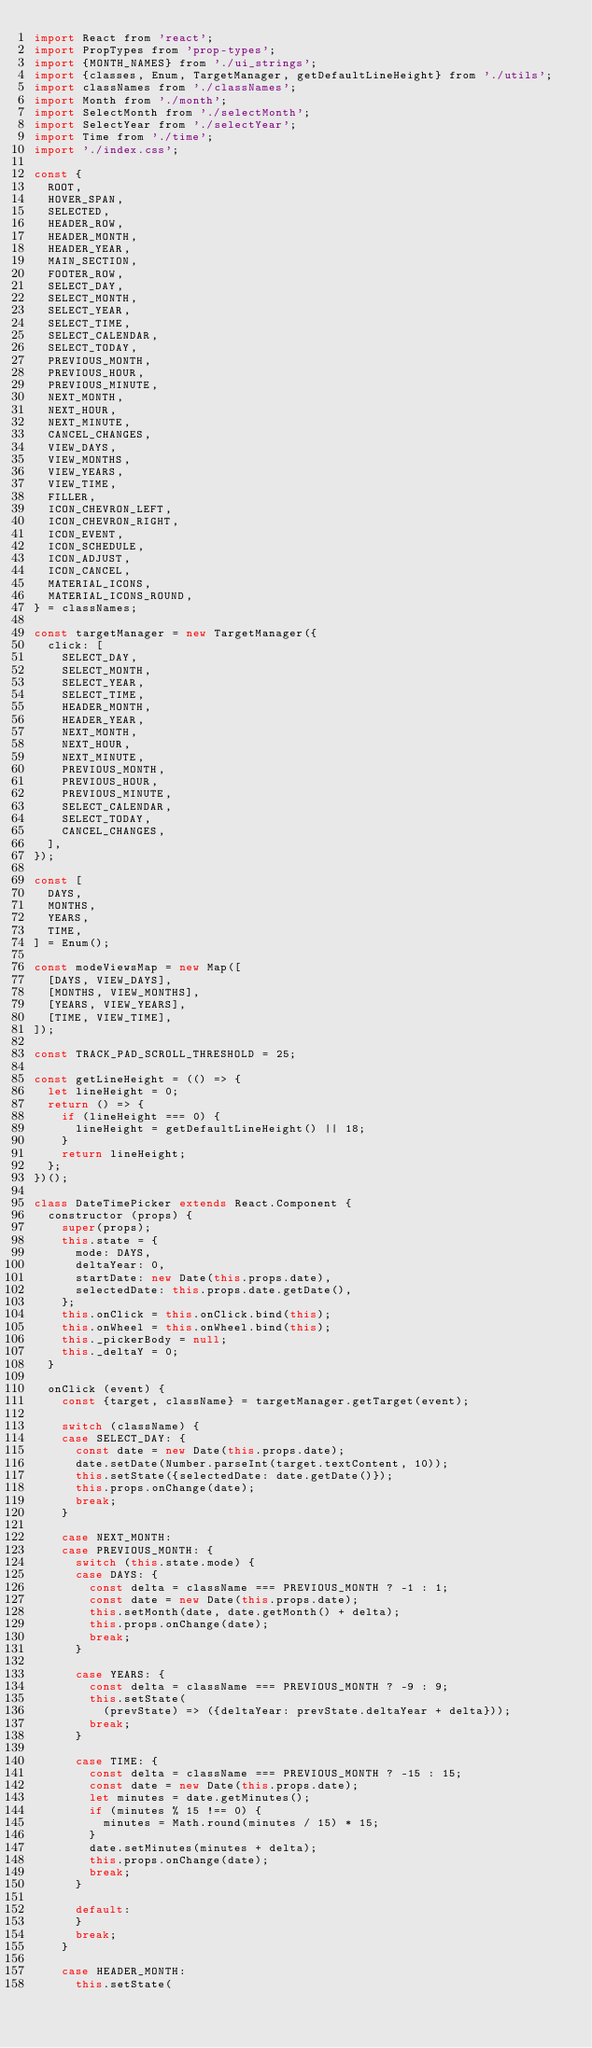<code> <loc_0><loc_0><loc_500><loc_500><_JavaScript_>import React from 'react';
import PropTypes from 'prop-types';
import {MONTH_NAMES} from './ui_strings';
import {classes, Enum, TargetManager, getDefaultLineHeight} from './utils';
import classNames from './classNames';
import Month from './month';
import SelectMonth from './selectMonth';
import SelectYear from './selectYear';
import Time from './time';
import './index.css';

const {
  ROOT,
  HOVER_SPAN,
  SELECTED,
  HEADER_ROW,
  HEADER_MONTH,
  HEADER_YEAR,
  MAIN_SECTION,
  FOOTER_ROW,
  SELECT_DAY,
  SELECT_MONTH,
  SELECT_YEAR,
  SELECT_TIME,
  SELECT_CALENDAR,
  SELECT_TODAY,
  PREVIOUS_MONTH,
  PREVIOUS_HOUR,
  PREVIOUS_MINUTE,
  NEXT_MONTH,
  NEXT_HOUR,
  NEXT_MINUTE,
  CANCEL_CHANGES,
  VIEW_DAYS,
  VIEW_MONTHS,
  VIEW_YEARS,
  VIEW_TIME,
  FILLER,
  ICON_CHEVRON_LEFT,
  ICON_CHEVRON_RIGHT,
  ICON_EVENT,
  ICON_SCHEDULE,
  ICON_ADJUST,
  ICON_CANCEL,
  MATERIAL_ICONS,
  MATERIAL_ICONS_ROUND,
} = classNames;

const targetManager = new TargetManager({
  click: [
    SELECT_DAY,
    SELECT_MONTH,
    SELECT_YEAR,
    SELECT_TIME,
    HEADER_MONTH,
    HEADER_YEAR,
    NEXT_MONTH,
    NEXT_HOUR,
    NEXT_MINUTE,
    PREVIOUS_MONTH,
    PREVIOUS_HOUR,
    PREVIOUS_MINUTE,
    SELECT_CALENDAR,
    SELECT_TODAY,
    CANCEL_CHANGES,
  ],
});

const [
  DAYS,
  MONTHS,
  YEARS,
  TIME,
] = Enum();

const modeViewsMap = new Map([
  [DAYS, VIEW_DAYS],
  [MONTHS, VIEW_MONTHS],
  [YEARS, VIEW_YEARS],
  [TIME, VIEW_TIME],
]);

const TRACK_PAD_SCROLL_THRESHOLD = 25;

const getLineHeight = (() => {
  let lineHeight = 0;
  return () => {
    if (lineHeight === 0) {
      lineHeight = getDefaultLineHeight() || 18;
    }
    return lineHeight;
  };
})();

class DateTimePicker extends React.Component {
  constructor (props) {
    super(props);
    this.state = {
      mode: DAYS,
      deltaYear: 0,
      startDate: new Date(this.props.date),
      selectedDate: this.props.date.getDate(),
    };
    this.onClick = this.onClick.bind(this);
    this.onWheel = this.onWheel.bind(this);
    this._pickerBody = null;
    this._deltaY = 0;
  }

  onClick (event) {
    const {target, className} = targetManager.getTarget(event);

    switch (className) {
    case SELECT_DAY: {
      const date = new Date(this.props.date);
      date.setDate(Number.parseInt(target.textContent, 10));
      this.setState({selectedDate: date.getDate()});
      this.props.onChange(date);
      break;
    }

    case NEXT_MONTH:
    case PREVIOUS_MONTH: {
      switch (this.state.mode) {
      case DAYS: {
        const delta = className === PREVIOUS_MONTH ? -1 : 1;
        const date = new Date(this.props.date);
        this.setMonth(date, date.getMonth() + delta);
        this.props.onChange(date);
        break;
      }

      case YEARS: {
        const delta = className === PREVIOUS_MONTH ? -9 : 9;
        this.setState(
          (prevState) => ({deltaYear: prevState.deltaYear + delta}));
        break;
      }

      case TIME: {
        const delta = className === PREVIOUS_MONTH ? -15 : 15;
        const date = new Date(this.props.date);
        let minutes = date.getMinutes();
        if (minutes % 15 !== 0) {
          minutes = Math.round(minutes / 15) * 15;
        }
        date.setMinutes(minutes + delta);
        this.props.onChange(date);
        break;
      }

      default:
      }
      break;
    }

    case HEADER_MONTH:
      this.setState(</code> 